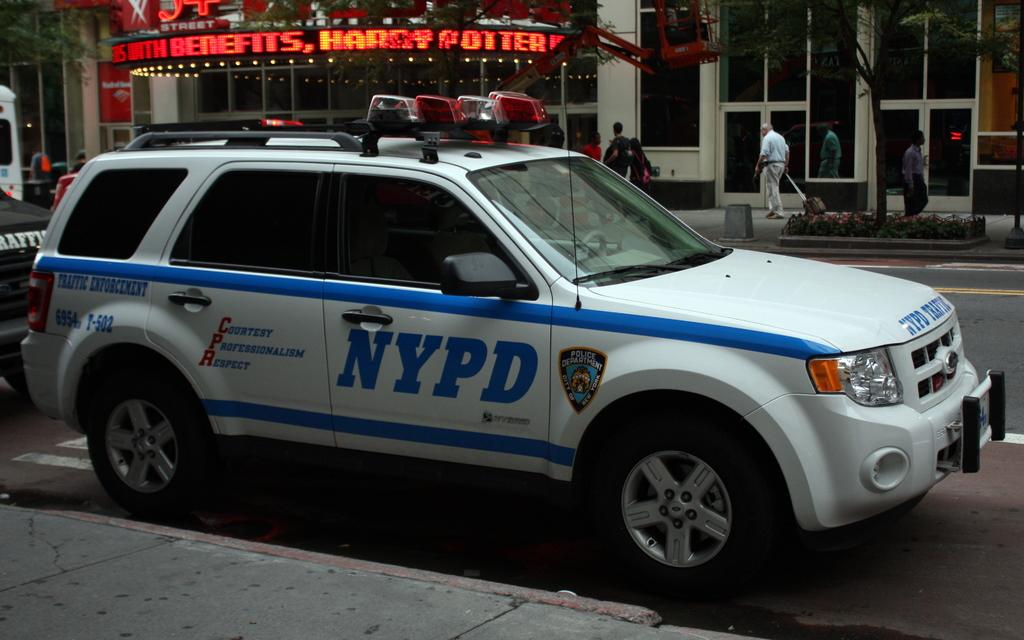What type of vehicle is in the image? There is a white car in the image. Where is the car located in the image? The car is parked on the roadside. What can be seen in the background of the image? There are shops visible in the background. What feature do the shops' doors have? The shops have glass doors. What type of language is spoken by the pies in the image? There are no pies present in the image, so it is not possible to determine what language they might speak. 